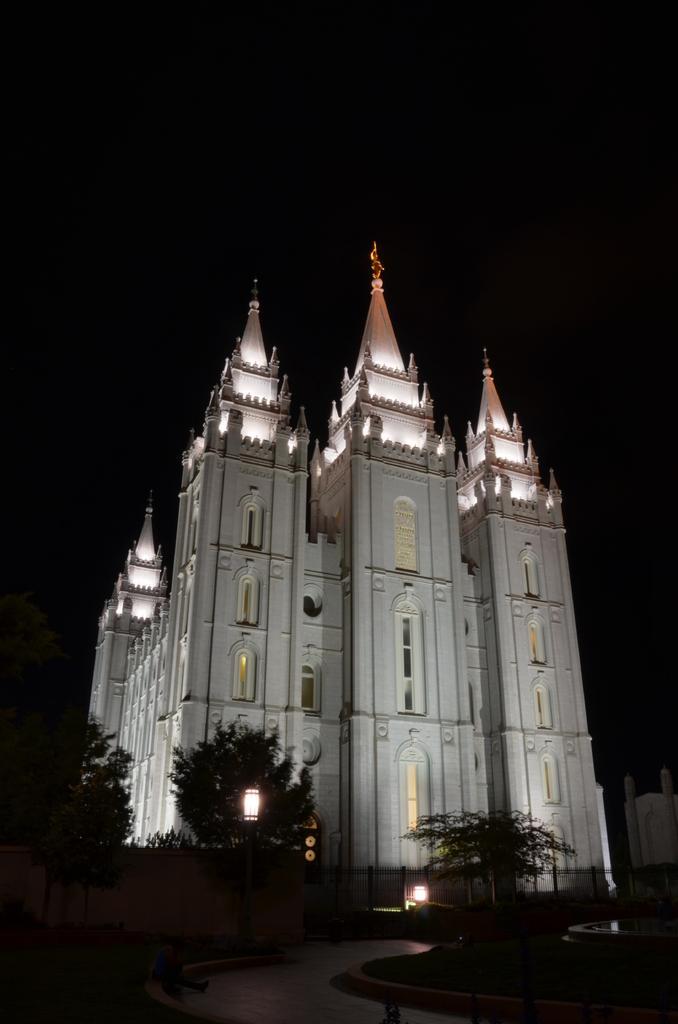In one or two sentences, can you explain what this image depicts? In this picture there is a church. In front of the church we can see trees, plants and street light. On the bottom right there is a building near to the church. At the top we can see darkness. 